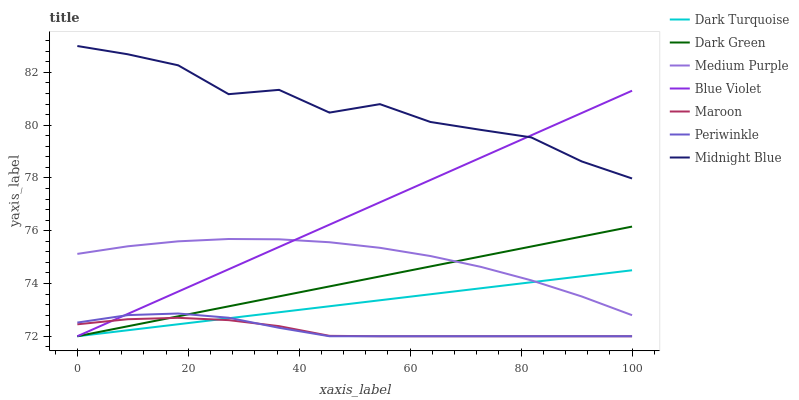Does Maroon have the minimum area under the curve?
Answer yes or no. Yes. Does Midnight Blue have the maximum area under the curve?
Answer yes or no. Yes. Does Dark Turquoise have the minimum area under the curve?
Answer yes or no. No. Does Dark Turquoise have the maximum area under the curve?
Answer yes or no. No. Is Dark Green the smoothest?
Answer yes or no. Yes. Is Midnight Blue the roughest?
Answer yes or no. Yes. Is Dark Turquoise the smoothest?
Answer yes or no. No. Is Dark Turquoise the roughest?
Answer yes or no. No. Does Dark Turquoise have the lowest value?
Answer yes or no. Yes. Does Medium Purple have the lowest value?
Answer yes or no. No. Does Midnight Blue have the highest value?
Answer yes or no. Yes. Does Dark Turquoise have the highest value?
Answer yes or no. No. Is Maroon less than Midnight Blue?
Answer yes or no. Yes. Is Medium Purple greater than Periwinkle?
Answer yes or no. Yes. Does Dark Turquoise intersect Maroon?
Answer yes or no. Yes. Is Dark Turquoise less than Maroon?
Answer yes or no. No. Is Dark Turquoise greater than Maroon?
Answer yes or no. No. Does Maroon intersect Midnight Blue?
Answer yes or no. No. 